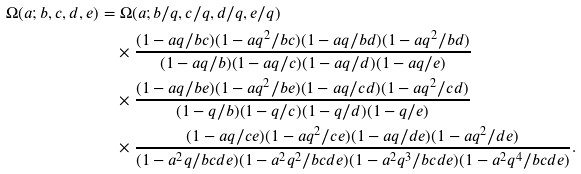<formula> <loc_0><loc_0><loc_500><loc_500>\Omega ( a ; b , c , d , e ) & = \Omega ( a ; b / q , c / q , d / q , e / q ) \\ & \quad \times \frac { ( 1 - a q / b c ) ( 1 - a q ^ { 2 } / b c ) ( 1 - a q / b d ) ( 1 - a q ^ { 2 } / b d ) } { ( 1 - a q / b ) ( 1 - a q / c ) ( 1 - a q / d ) ( 1 - a q / e ) } \\ & \quad \times \frac { ( 1 - a q / b e ) ( 1 - a q ^ { 2 } / b e ) ( 1 - a q / c d ) ( 1 - a q ^ { 2 } / c d ) } { ( 1 - q / b ) ( 1 - q / c ) ( 1 - q / d ) ( 1 - q / e ) } \\ & \quad \times \frac { ( 1 - a q / c e ) ( 1 - a q ^ { 2 } / c e ) ( 1 - a q / d e ) ( 1 - a q ^ { 2 } / d e ) } { ( 1 - a ^ { 2 } q / b c d e ) ( 1 - a ^ { 2 } q ^ { 2 } / b c d e ) ( 1 - a ^ { 2 } q ^ { 3 } / b c d e ) ( 1 - a ^ { 2 } q ^ { 4 } / b c d e ) } .</formula> 